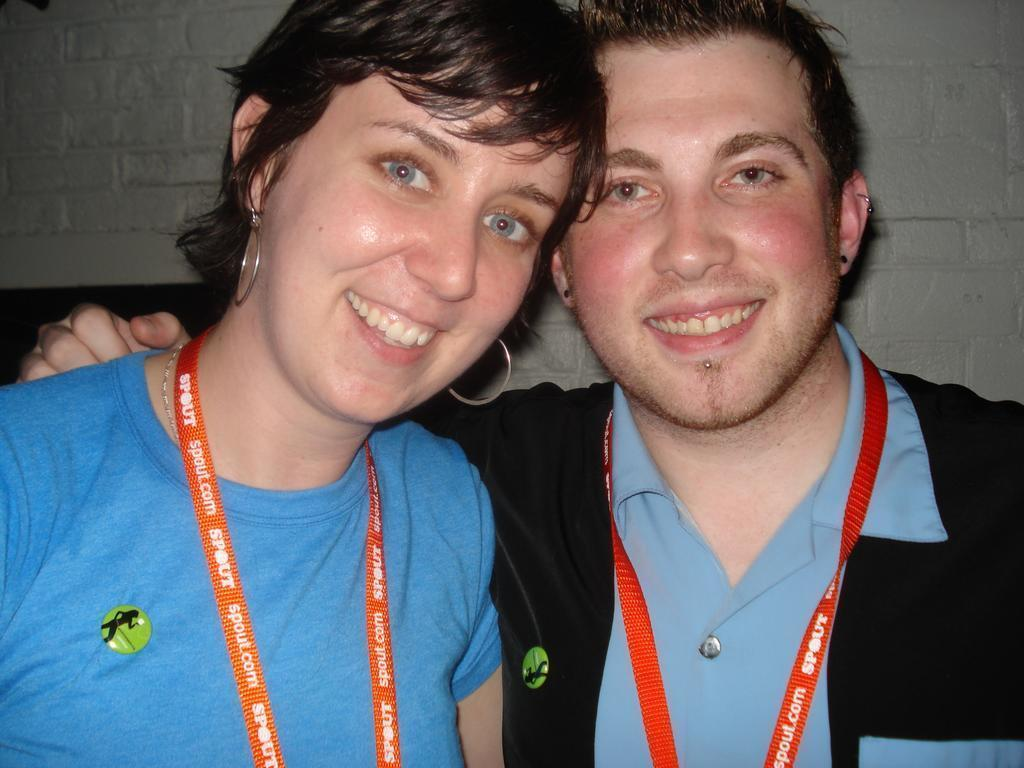How many people are present in the image? There are two people in the image. What is the facial expression of the people in the image? The people are smiling. What objects can be seen in the image that are made of wire? There are wire tags in the image. What can be seen in the background of the image? There is a wall visible in the background of the image. What type of linen is being used to cover the actor in the image? There is no actor or linen present in the image; it features two people and wire tags. What type of iron is visible in the image? There is no iron present in the image. 